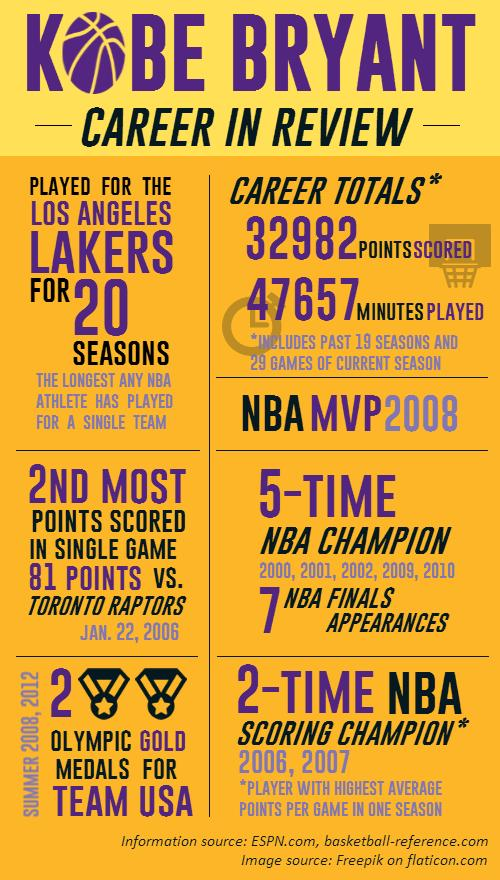Mention a couple of crucial points in this snapshot. Kobe Bryant won Olympic gold medals for Team USA in 2008 and 2012. Kobe Bryant won the NBA scoring champion title in the years 2006 and 2007. 